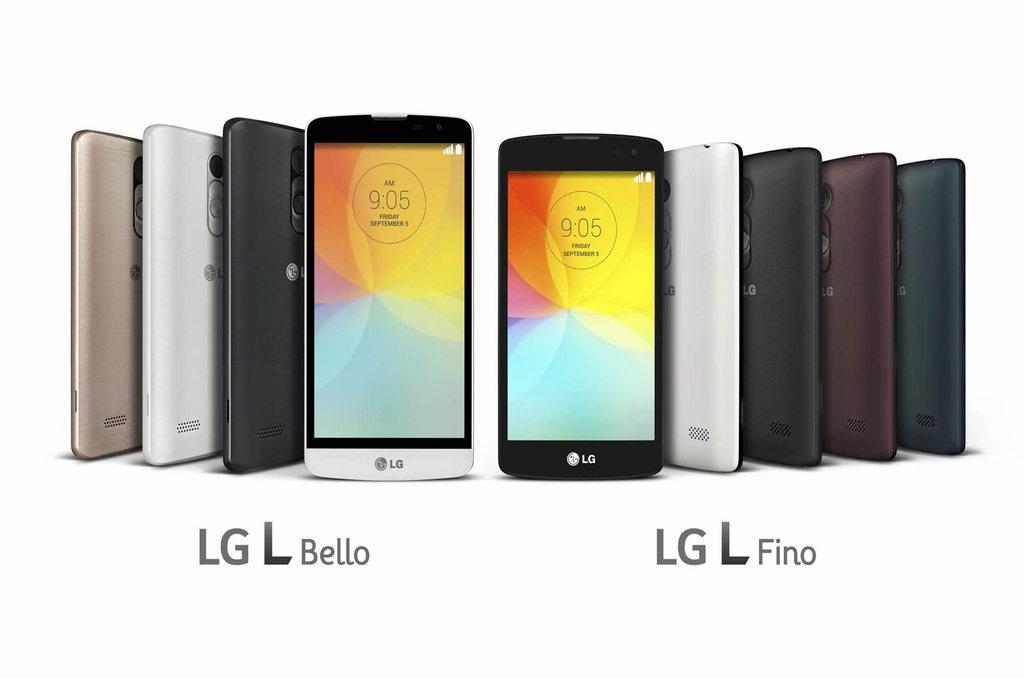<image>
Write a terse but informative summary of the picture. LG Bello and LG Fino phones next to each other. 